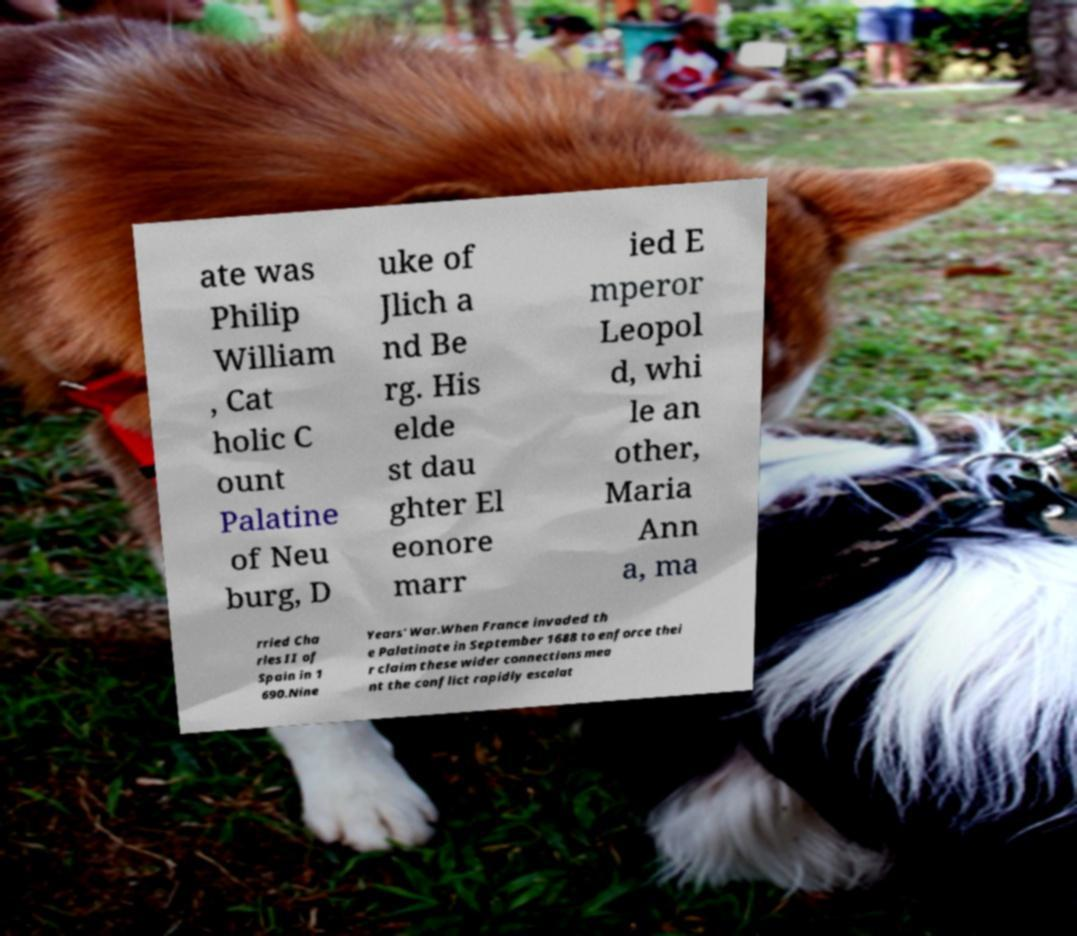Please read and relay the text visible in this image. What does it say? ate was Philip William , Cat holic C ount Palatine of Neu burg, D uke of Jlich a nd Be rg. His elde st dau ghter El eonore marr ied E mperor Leopol d, whi le an other, Maria Ann a, ma rried Cha rles II of Spain in 1 690.Nine Years' War.When France invaded th e Palatinate in September 1688 to enforce thei r claim these wider connections mea nt the conflict rapidly escalat 